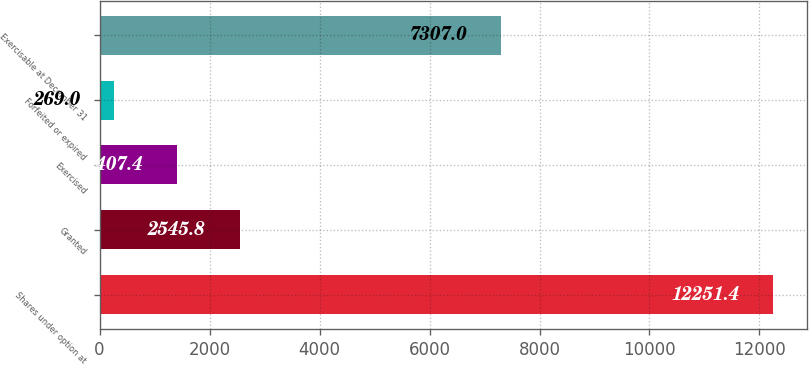<chart> <loc_0><loc_0><loc_500><loc_500><bar_chart><fcel>Shares under option at<fcel>Granted<fcel>Exercised<fcel>Forfeited or expired<fcel>Exercisable at December 31<nl><fcel>12251.4<fcel>2545.8<fcel>1407.4<fcel>269<fcel>7307<nl></chart> 